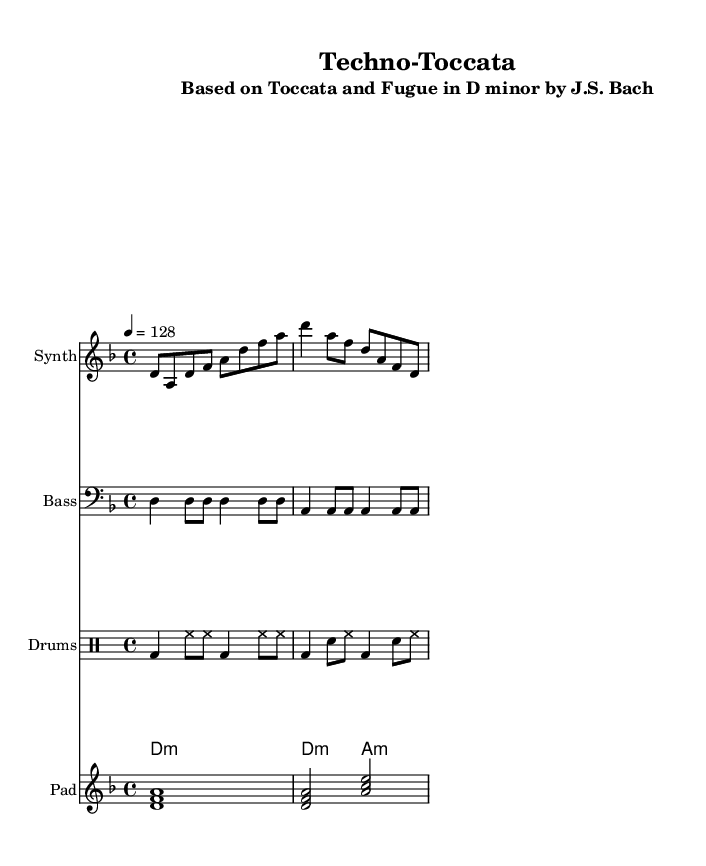What is the key signature of this music? The key signature indicated in the global section of the code specifies the piece is in D minor, which typically has one flat (B flat) as its only alteration.
Answer: D minor What is the time signature of this music? The time signature specified in the global section of the code is 4/4, meaning there are four beats per measure and the quarter note gets one beat.
Answer: 4/4 What is the tempo marking of this music? The tempo marking is set to 128 beats per minute, indicated in the global section, meaning the piece should be played moderately fast.
Answer: 128 How many measures are shown in the synthesizer part? The synthesizer part, as coded, consists of a total of four measures as determined by the rhythm pattern, which can be counted when looking at the notation.
Answer: 4 Which classical composition is referenced in this piece? The subtitle of the score explicitly states that the piece is based on "Toccata and Fugue in D minor" by J.S. Bach, connecting it to a well-known classical composition.
Answer: Toccata and Fugue in D minor by J.S. Bach What type of instruments are included in this arrangement? The layout includes four different types of musical instruments: synthesizer, bass, drums, and pad, which together create a rich electronic sound.
Answer: Synthesizer, Bass, Drums, Pad What rhythmic pattern is used for the drums? The drumming pattern is organized in drum notation and consists of kick drum, hi-hat, and snare, typically giving a driving beat characteristic of dance music.
Answer: Kick, Hi-hat, Snare 